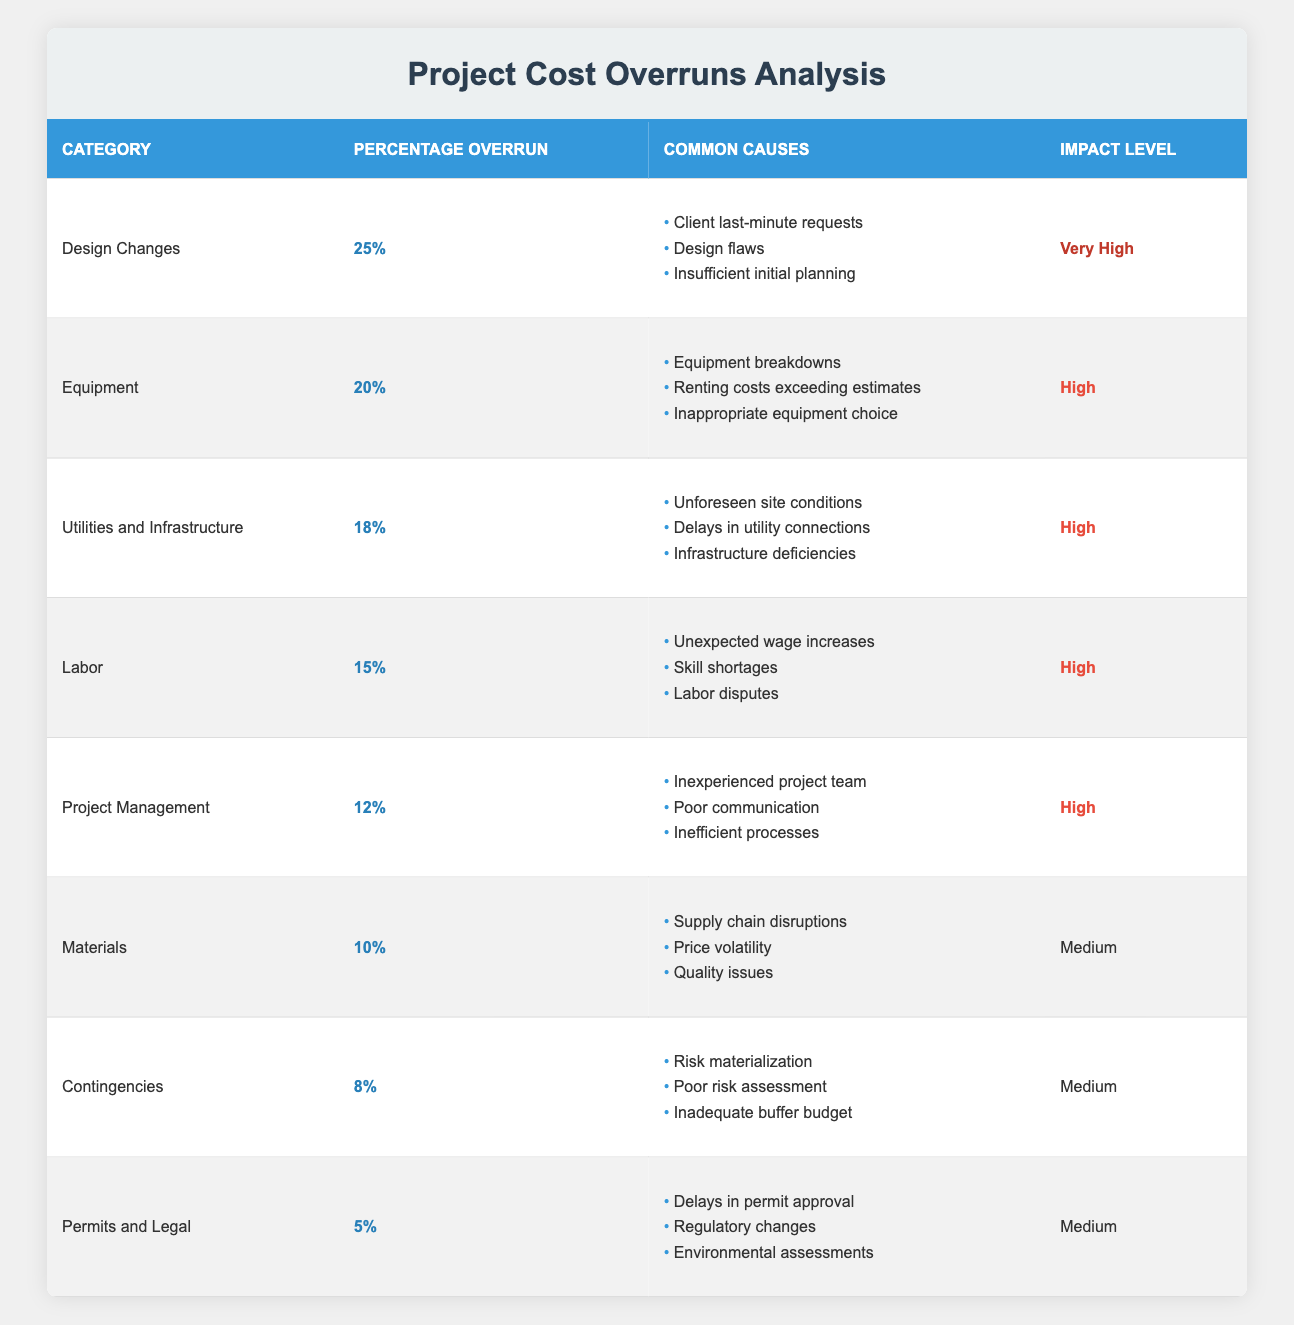What is the category with the highest percentage overrun? The category with the highest percentage overrun listed in the table is "Design Changes," which has a percentage overrun of 25%.
Answer: Design Changes How many categories have an impact level classified as "High"? From the table, the categories with an impact level of "High" are "Equipment," "Labor," "Project Management," and "Utilities and Infrastructure." This totals four categories.
Answer: 4 Is there a category where the percentage overrun is less than 10%? Checking the table, the "Permits and Legal" category has a percentage overrun of 5%, which is less than 10%.
Answer: Yes What percentage overrun do "Materials" and "Labor" categories have combined? The percentage overrun for "Materials" is 10% and for "Labor" is 15%. Their combined percentage is 10 + 15 = 25%.
Answer: 25% Which categories have common causes related to supply chain issues? The category "Materials" has common causes that include "Supply chain disruptions." Additionally, while "Utilities and Infrastructure" does not mention supply chain issues explicitly, it signifies unforeseen conditions which could be related. However, only "Materials" lists supply chain disruptions directly.
Answer: Materials What is the average percentage overrun across all the categories listed? The percentages for all the categories are 25, 20, 18, 15, 12, 10, 8, and 5. Adding these gives 25 + 20 + 18 + 15 + 12 + 10 + 8 + 5 = 113. There are 8 categories, so the average is 113 / 8 = 14.125, which can be rounded to 14.13.
Answer: 14.13 Are there more categories with "Medium" impact levels than with "High" impact levels? Based on the table, there are three categories with "Medium" impact levels ("Materials," "Permits and Legal," and "Contingencies") and four categories classified as "High." Therefore, there are fewer "Medium" impact level categories.
Answer: No What is the total percentage overrun associated with "Permits and Legal" and "Contingencies"? The percentage overrun for "Permits and Legal" is 5% and for "Contingencies" is 8%. Their total percentage overrun is 5 + 8 = 13%.
Answer: 13% 